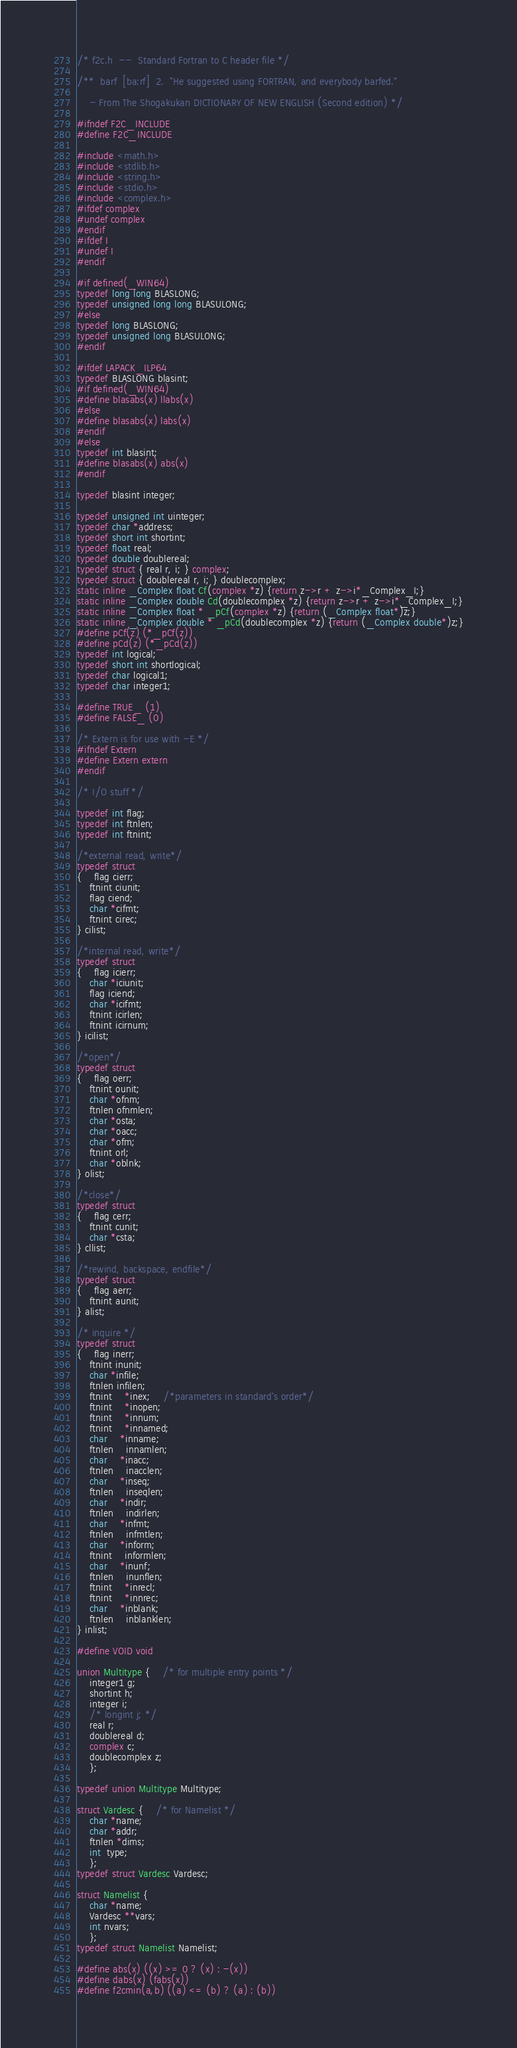Convert code to text. <code><loc_0><loc_0><loc_500><loc_500><_C_>/* f2c.h  --  Standard Fortran to C header file */

/**  barf  [ba:rf]  2.  "He suggested using FORTRAN, and everybody barfed."

	- From The Shogakukan DICTIONARY OF NEW ENGLISH (Second edition) */

#ifndef F2C_INCLUDE
#define F2C_INCLUDE

#include <math.h>
#include <stdlib.h>
#include <string.h>
#include <stdio.h>
#include <complex.h>
#ifdef complex
#undef complex
#endif
#ifdef I
#undef I
#endif

#if defined(_WIN64)
typedef long long BLASLONG;
typedef unsigned long long BLASULONG;
#else
typedef long BLASLONG;
typedef unsigned long BLASULONG;
#endif

#ifdef LAPACK_ILP64
typedef BLASLONG blasint;
#if defined(_WIN64)
#define blasabs(x) llabs(x)
#else
#define blasabs(x) labs(x)
#endif
#else
typedef int blasint;
#define blasabs(x) abs(x)
#endif

typedef blasint integer;

typedef unsigned int uinteger;
typedef char *address;
typedef short int shortint;
typedef float real;
typedef double doublereal;
typedef struct { real r, i; } complex;
typedef struct { doublereal r, i; } doublecomplex;
static inline _Complex float Cf(complex *z) {return z->r + z->i*_Complex_I;}
static inline _Complex double Cd(doublecomplex *z) {return z->r + z->i*_Complex_I;}
static inline _Complex float * _pCf(complex *z) {return (_Complex float*)z;}
static inline _Complex double * _pCd(doublecomplex *z) {return (_Complex double*)z;}
#define pCf(z) (*_pCf(z))
#define pCd(z) (*_pCd(z))
typedef int logical;
typedef short int shortlogical;
typedef char logical1;
typedef char integer1;

#define TRUE_ (1)
#define FALSE_ (0)

/* Extern is for use with -E */
#ifndef Extern
#define Extern extern
#endif

/* I/O stuff */

typedef int flag;
typedef int ftnlen;
typedef int ftnint;

/*external read, write*/
typedef struct
{	flag cierr;
	ftnint ciunit;
	flag ciend;
	char *cifmt;
	ftnint cirec;
} cilist;

/*internal read, write*/
typedef struct
{	flag icierr;
	char *iciunit;
	flag iciend;
	char *icifmt;
	ftnint icirlen;
	ftnint icirnum;
} icilist;

/*open*/
typedef struct
{	flag oerr;
	ftnint ounit;
	char *ofnm;
	ftnlen ofnmlen;
	char *osta;
	char *oacc;
	char *ofm;
	ftnint orl;
	char *oblnk;
} olist;

/*close*/
typedef struct
{	flag cerr;
	ftnint cunit;
	char *csta;
} cllist;

/*rewind, backspace, endfile*/
typedef struct
{	flag aerr;
	ftnint aunit;
} alist;

/* inquire */
typedef struct
{	flag inerr;
	ftnint inunit;
	char *infile;
	ftnlen infilen;
	ftnint	*inex;	/*parameters in standard's order*/
	ftnint	*inopen;
	ftnint	*innum;
	ftnint	*innamed;
	char	*inname;
	ftnlen	innamlen;
	char	*inacc;
	ftnlen	inacclen;
	char	*inseq;
	ftnlen	inseqlen;
	char 	*indir;
	ftnlen	indirlen;
	char	*infmt;
	ftnlen	infmtlen;
	char	*inform;
	ftnint	informlen;
	char	*inunf;
	ftnlen	inunflen;
	ftnint	*inrecl;
	ftnint	*innrec;
	char	*inblank;
	ftnlen	inblanklen;
} inlist;

#define VOID void

union Multitype {	/* for multiple entry points */
	integer1 g;
	shortint h;
	integer i;
	/* longint j; */
	real r;
	doublereal d;
	complex c;
	doublecomplex z;
	};

typedef union Multitype Multitype;

struct Vardesc {	/* for Namelist */
	char *name;
	char *addr;
	ftnlen *dims;
	int  type;
	};
typedef struct Vardesc Vardesc;

struct Namelist {
	char *name;
	Vardesc **vars;
	int nvars;
	};
typedef struct Namelist Namelist;

#define abs(x) ((x) >= 0 ? (x) : -(x))
#define dabs(x) (fabs(x))
#define f2cmin(a,b) ((a) <= (b) ? (a) : (b))</code> 